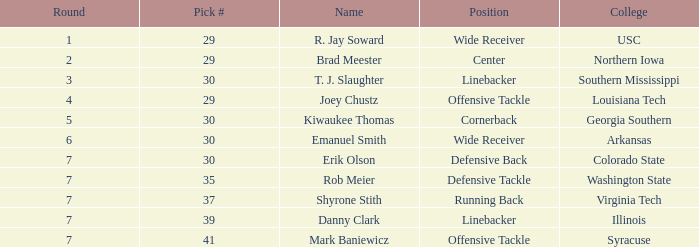What is the Position with a round 3 pick for r. jay soward? Wide Receiver. 